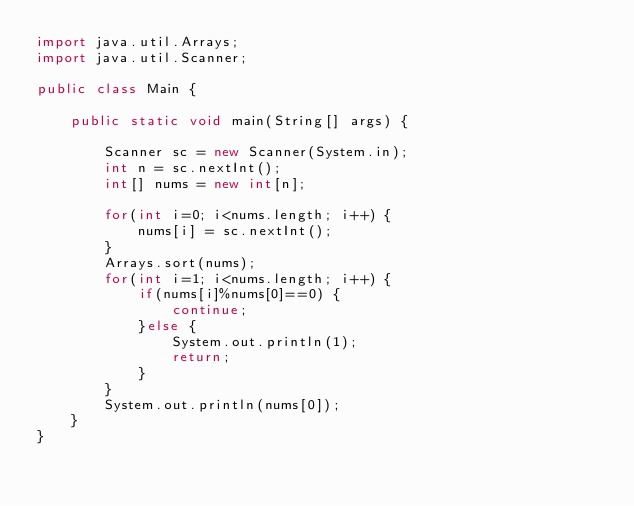<code> <loc_0><loc_0><loc_500><loc_500><_Java_>import java.util.Arrays;
import java.util.Scanner;

public class Main {

	public static void main(String[] args) {
		
		Scanner sc = new Scanner(System.in);
		int n = sc.nextInt();
		int[] nums = new int[n];
		
		for(int i=0; i<nums.length; i++) {
			nums[i] = sc.nextInt();
		}
		Arrays.sort(nums);
		for(int i=1; i<nums.length; i++) {
			if(nums[i]%nums[0]==0) {
				continue;
			}else {
				System.out.println(1);
				return;
			}
		}
		System.out.println(nums[0]);
	}
}
</code> 